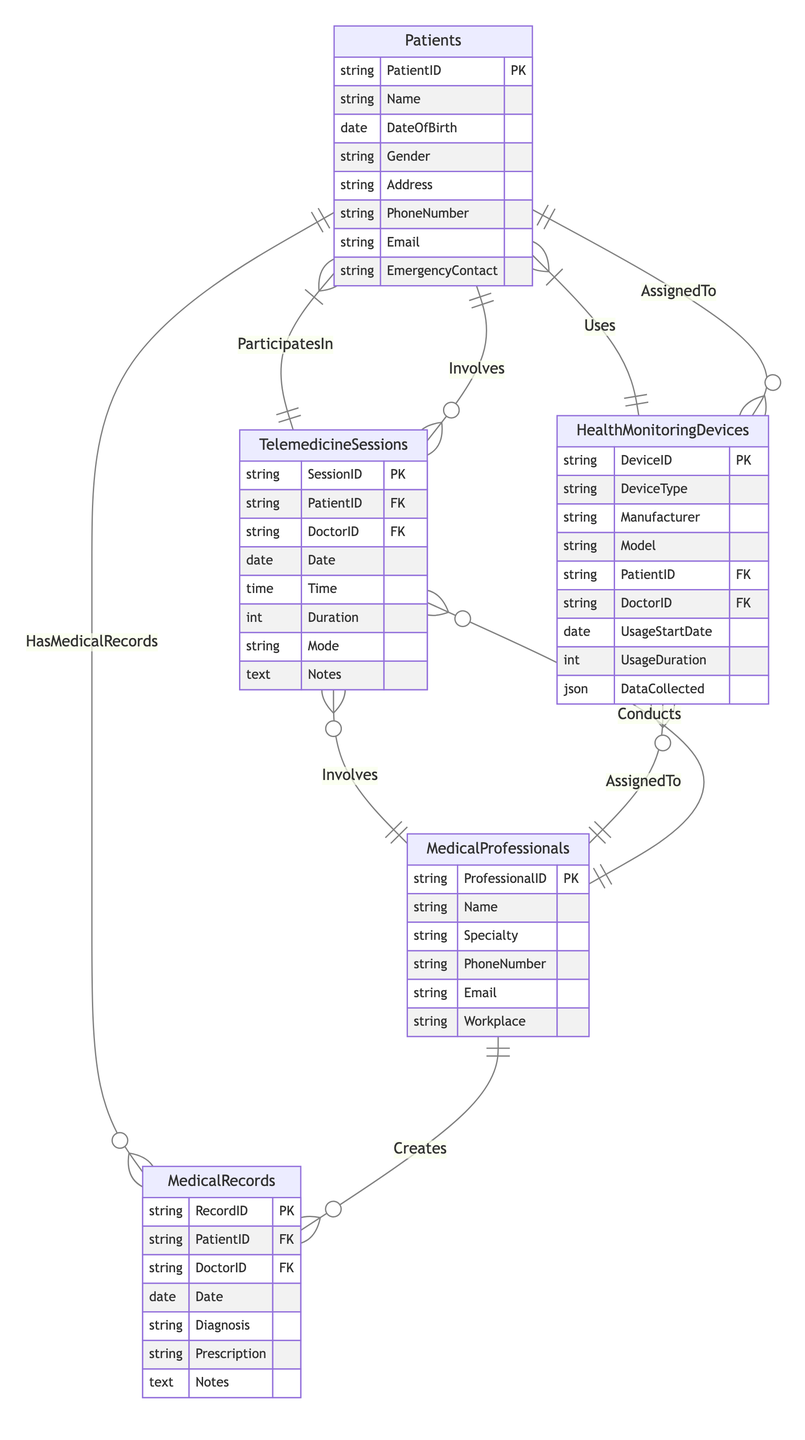What is the primary key for the Patients entity? The Patients entity has the attribute "PatientID" marked as the primary key (PK), which uniquely identifies each patient in the database.
Answer: PatientID How many entities are involved in the Telemedicine Sessions? The Telemedicine Sessions entity involves two entities: Patients and Medical Professionals, as shown by the composite relationship linking them to the sessions.
Answer: Two What relationship connects Medical Professionals to Medical Records? The Medical Professionals create Medical Records, represented as a one-to-many relationship, indicating that each medical professional can create multiple medical records.
Answer: Creates What type of relationship exists between Patients and Health Monitoring Devices? The relationship between Patients and Health Monitoring Devices is many-to-many, indicating that each patient can use multiple devices, and each device can be assigned to multiple patients.
Answer: ManyToMany How many attributes does the Telemedicine Sessions entity have? The Telemedicine Sessions entity has eight attributes listed, which include SessionID, PatientID, DoctorID, Date, Time, Duration, Mode, and Notes.
Answer: Eight In what entity is the attribute "Diagnosis" found? The attribute "Diagnosis" is found in the Medical Records entity, indicating it's a part of the detailed information collected for a patient's medical record.
Answer: MedicalRecords Who conducts Telemedicine Sessions? Telemedicine Sessions are conducted by Medical Professionals, as evidenced by the one-to-many relationship depicted in the diagram.
Answer: Medical Professionals What is the type of data collected by Health Monitoring Devices? The Health Monitoring Devices entity includes an attribute named "DataCollected", which specifies it collects data in the JSON format.
Answer: JSON How many relationships are defined for the Health Monitoring Devices entity? The Health Monitoring Devices entity has one relationship defined, which is "AssignedTo", indicating its association with both Patients and Medical Professionals.
Answer: One What is the foreign key in the Medical Records entity? The foreign key in the Medical Records entity is "PatientID", which establishes a link between medical records and the corresponding patient.
Answer: PatientID 